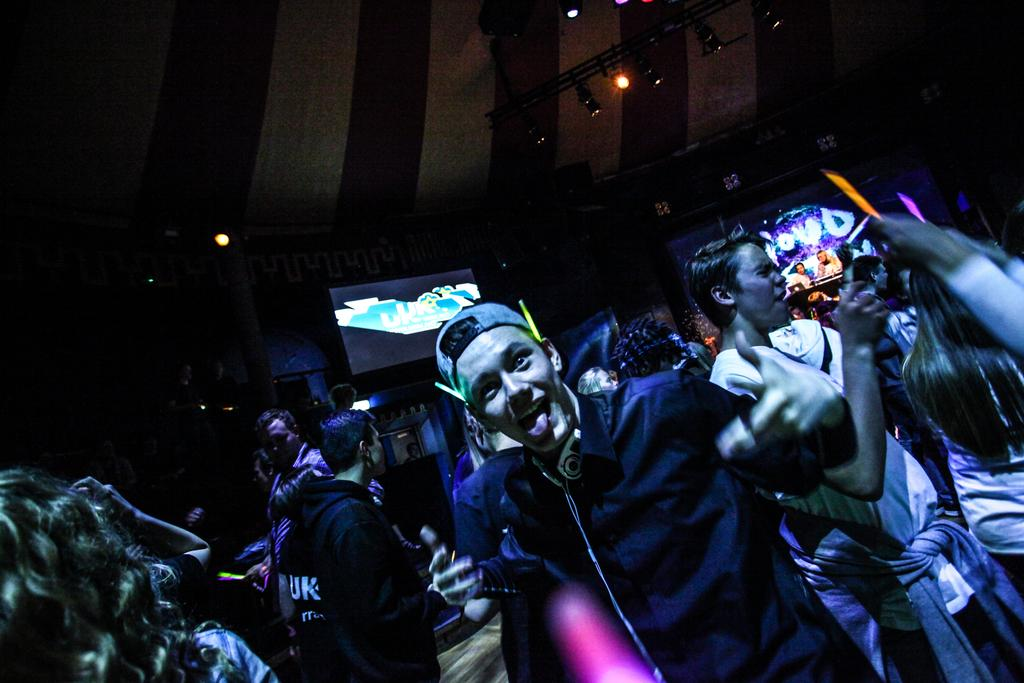What can be seen in the image? There is a group of people in the image. How are the people dressed? The people are wearing different color dresses. Can you identify any specific accessory worn by one of the people? One person is wearing a cap. What is visible in the background of the image? There are screens and lights visible in the top of the background. What channel are the people watching on the screens in the background? There is no information about the content on the screens, so we cannot determine what channel they might be watching. 